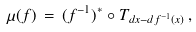Convert formula to latex. <formula><loc_0><loc_0><loc_500><loc_500>\mu ( f ) \, = \, ( f ^ { - 1 } ) ^ { * } \circ T _ { d x - d f ^ { - 1 } ( x ) } \, ,</formula> 